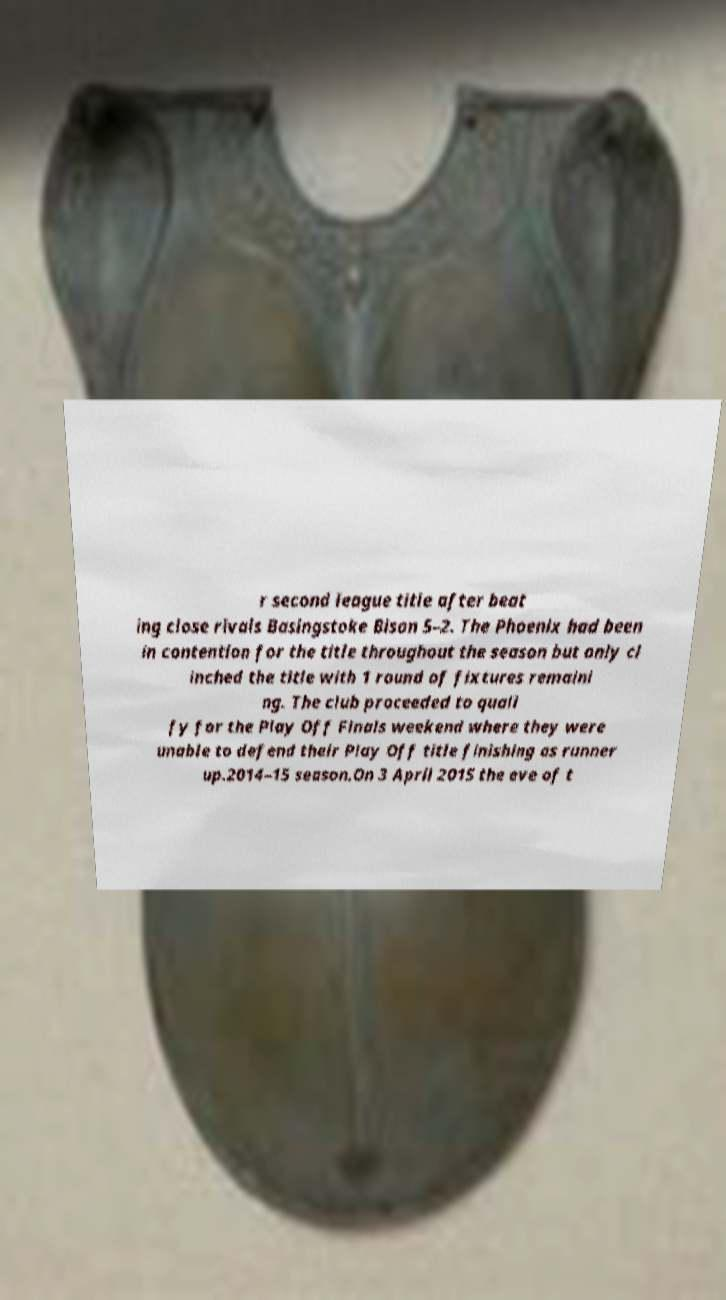Can you read and provide the text displayed in the image?This photo seems to have some interesting text. Can you extract and type it out for me? r second league title after beat ing close rivals Basingstoke Bison 5–2. The Phoenix had been in contention for the title throughout the season but only cl inched the title with 1 round of fixtures remaini ng. The club proceeded to quali fy for the Play Off Finals weekend where they were unable to defend their Play Off title finishing as runner up.2014–15 season.On 3 April 2015 the eve of t 